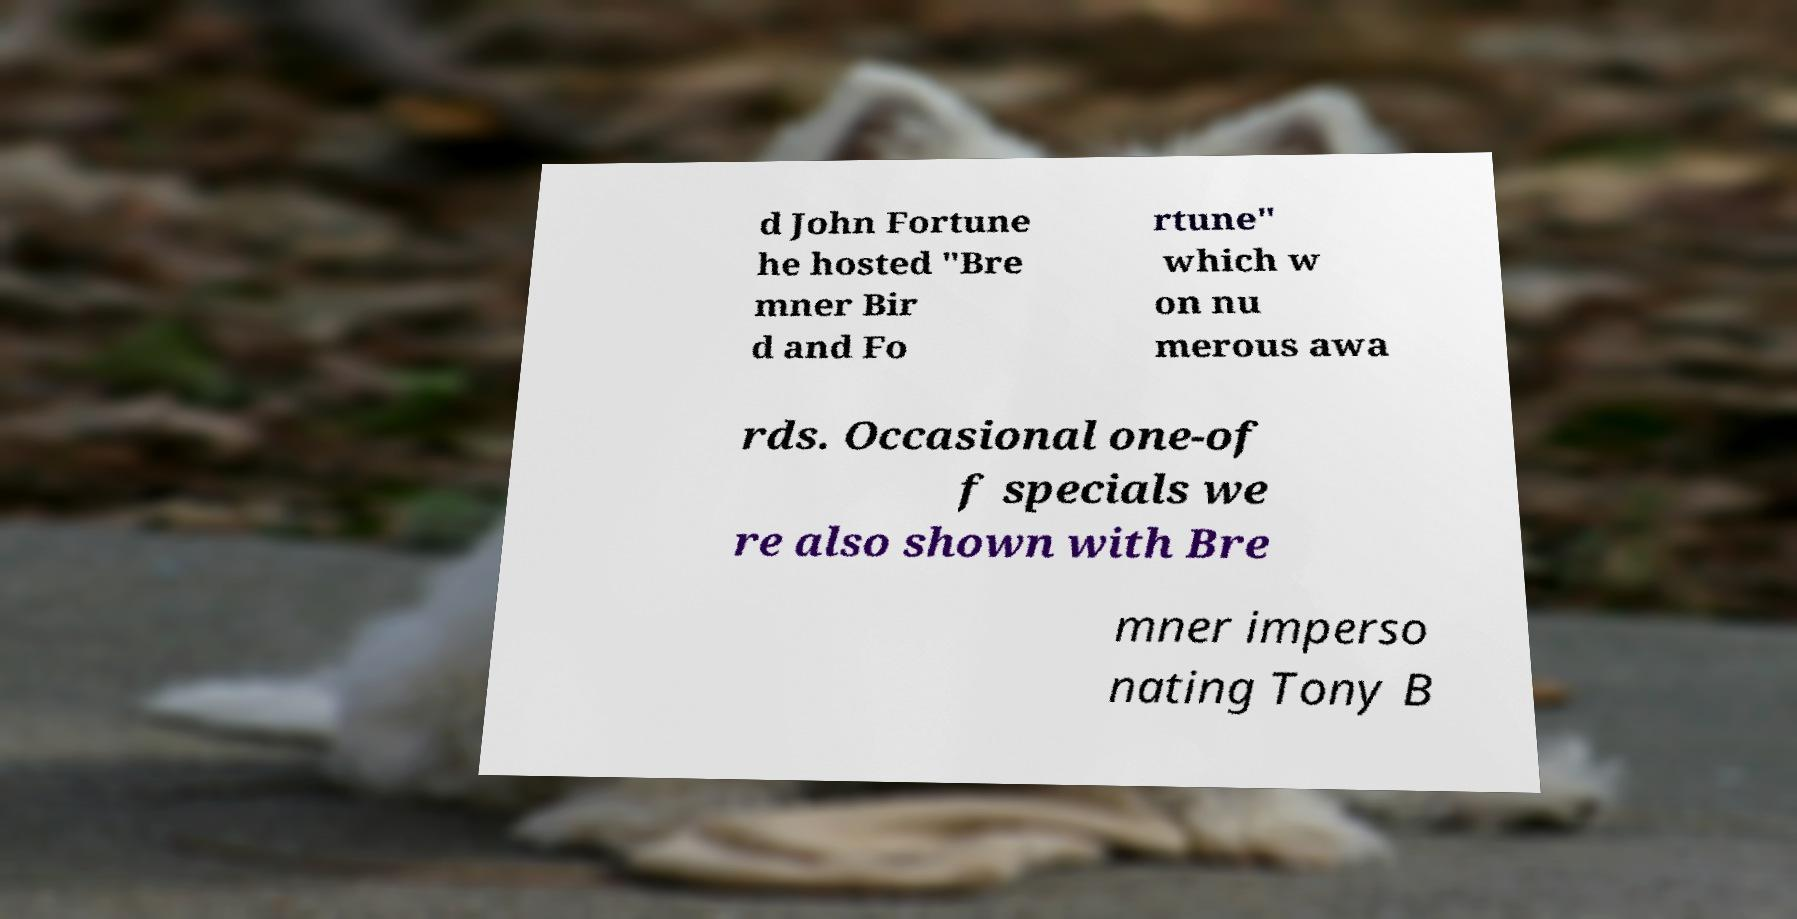I need the written content from this picture converted into text. Can you do that? d John Fortune he hosted "Bre mner Bir d and Fo rtune" which w on nu merous awa rds. Occasional one-of f specials we re also shown with Bre mner imperso nating Tony B 